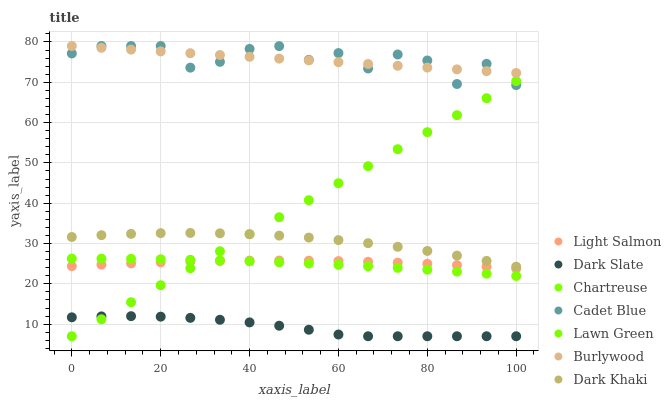Does Dark Slate have the minimum area under the curve?
Answer yes or no. Yes. Does Cadet Blue have the maximum area under the curve?
Answer yes or no. Yes. Does Light Salmon have the minimum area under the curve?
Answer yes or no. No. Does Light Salmon have the maximum area under the curve?
Answer yes or no. No. Is Lawn Green the smoothest?
Answer yes or no. Yes. Is Cadet Blue the roughest?
Answer yes or no. Yes. Is Light Salmon the smoothest?
Answer yes or no. No. Is Light Salmon the roughest?
Answer yes or no. No. Does Lawn Green have the lowest value?
Answer yes or no. Yes. Does Light Salmon have the lowest value?
Answer yes or no. No. Does Burlywood have the highest value?
Answer yes or no. Yes. Does Light Salmon have the highest value?
Answer yes or no. No. Is Light Salmon less than Dark Khaki?
Answer yes or no. Yes. Is Chartreuse greater than Dark Slate?
Answer yes or no. Yes. Does Burlywood intersect Cadet Blue?
Answer yes or no. Yes. Is Burlywood less than Cadet Blue?
Answer yes or no. No. Is Burlywood greater than Cadet Blue?
Answer yes or no. No. Does Light Salmon intersect Dark Khaki?
Answer yes or no. No. 